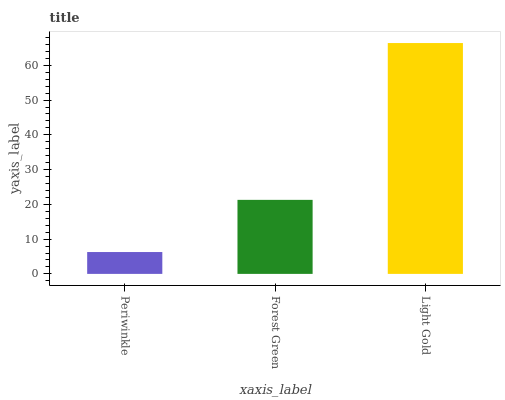Is Periwinkle the minimum?
Answer yes or no. Yes. Is Light Gold the maximum?
Answer yes or no. Yes. Is Forest Green the minimum?
Answer yes or no. No. Is Forest Green the maximum?
Answer yes or no. No. Is Forest Green greater than Periwinkle?
Answer yes or no. Yes. Is Periwinkle less than Forest Green?
Answer yes or no. Yes. Is Periwinkle greater than Forest Green?
Answer yes or no. No. Is Forest Green less than Periwinkle?
Answer yes or no. No. Is Forest Green the high median?
Answer yes or no. Yes. Is Forest Green the low median?
Answer yes or no. Yes. Is Light Gold the high median?
Answer yes or no. No. Is Light Gold the low median?
Answer yes or no. No. 